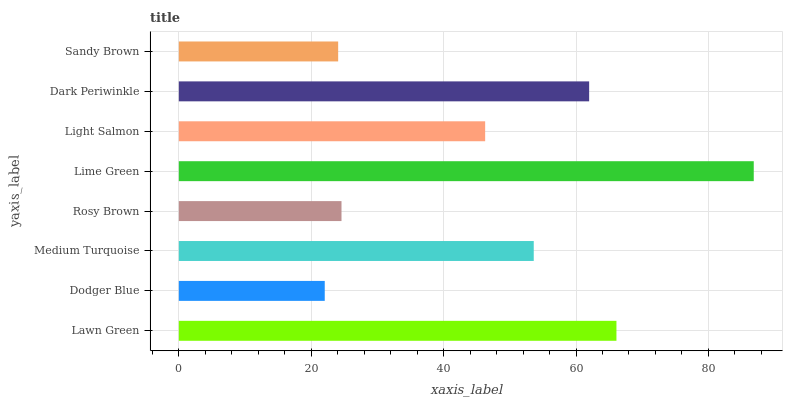Is Dodger Blue the minimum?
Answer yes or no. Yes. Is Lime Green the maximum?
Answer yes or no. Yes. Is Medium Turquoise the minimum?
Answer yes or no. No. Is Medium Turquoise the maximum?
Answer yes or no. No. Is Medium Turquoise greater than Dodger Blue?
Answer yes or no. Yes. Is Dodger Blue less than Medium Turquoise?
Answer yes or no. Yes. Is Dodger Blue greater than Medium Turquoise?
Answer yes or no. No. Is Medium Turquoise less than Dodger Blue?
Answer yes or no. No. Is Medium Turquoise the high median?
Answer yes or no. Yes. Is Light Salmon the low median?
Answer yes or no. Yes. Is Light Salmon the high median?
Answer yes or no. No. Is Lawn Green the low median?
Answer yes or no. No. 